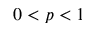Convert formula to latex. <formula><loc_0><loc_0><loc_500><loc_500>0 < p < 1</formula> 